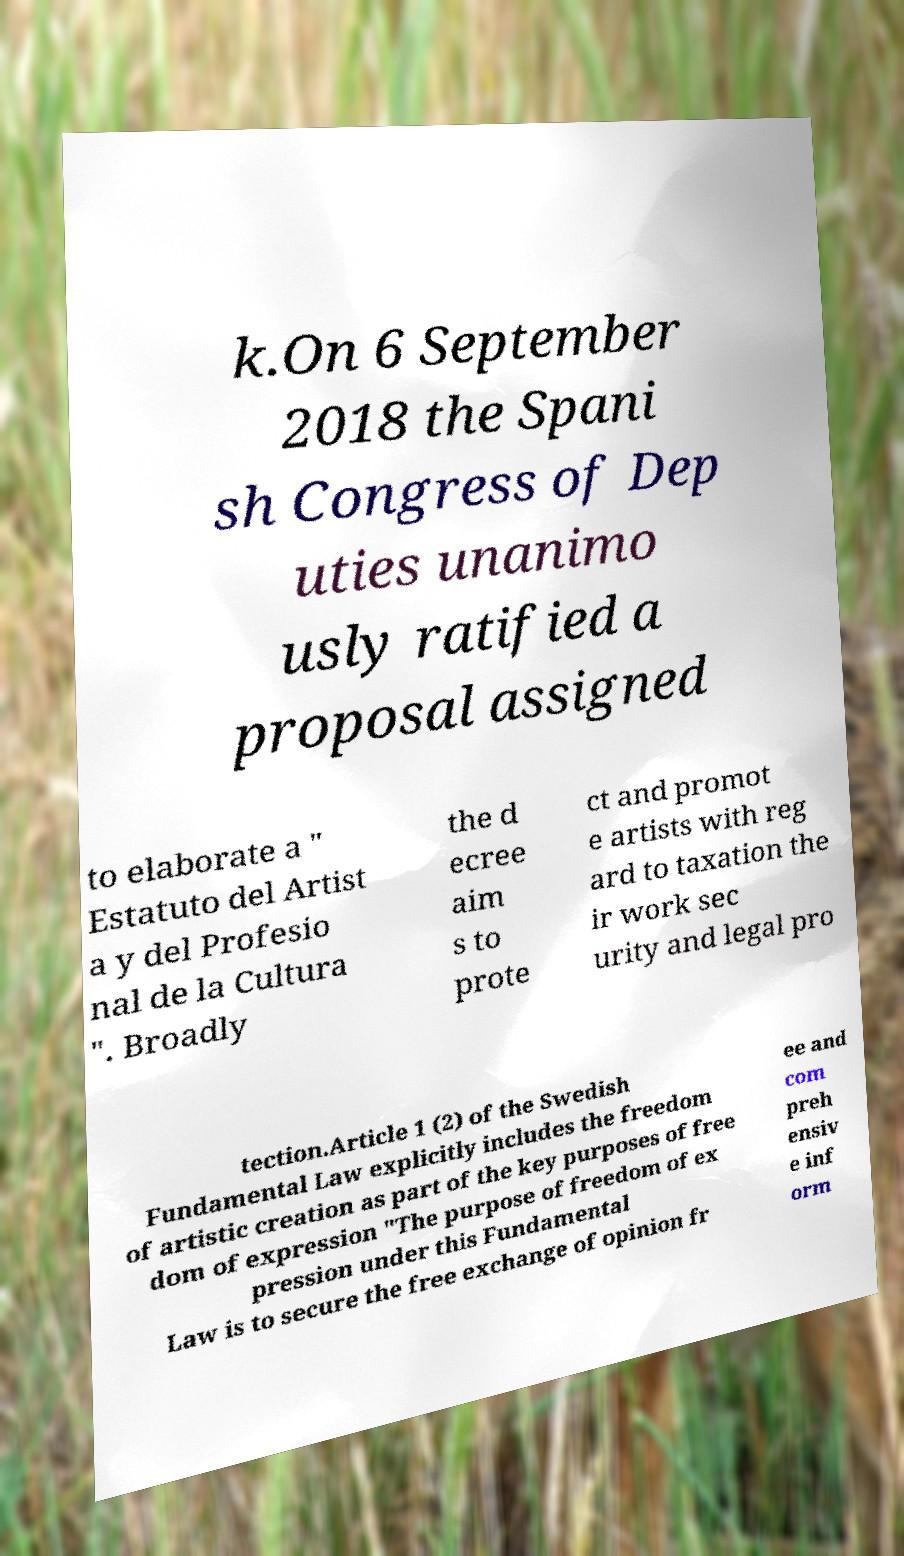I need the written content from this picture converted into text. Can you do that? k.On 6 September 2018 the Spani sh Congress of Dep uties unanimo usly ratified a proposal assigned to elaborate a " Estatuto del Artist a y del Profesio nal de la Cultura ". Broadly the d ecree aim s to prote ct and promot e artists with reg ard to taxation the ir work sec urity and legal pro tection.Article 1 (2) of the Swedish Fundamental Law explicitly includes the freedom of artistic creation as part of the key purposes of free dom of expression "The purpose of freedom of ex pression under this Fundamental Law is to secure the free exchange of opinion fr ee and com preh ensiv e inf orm 